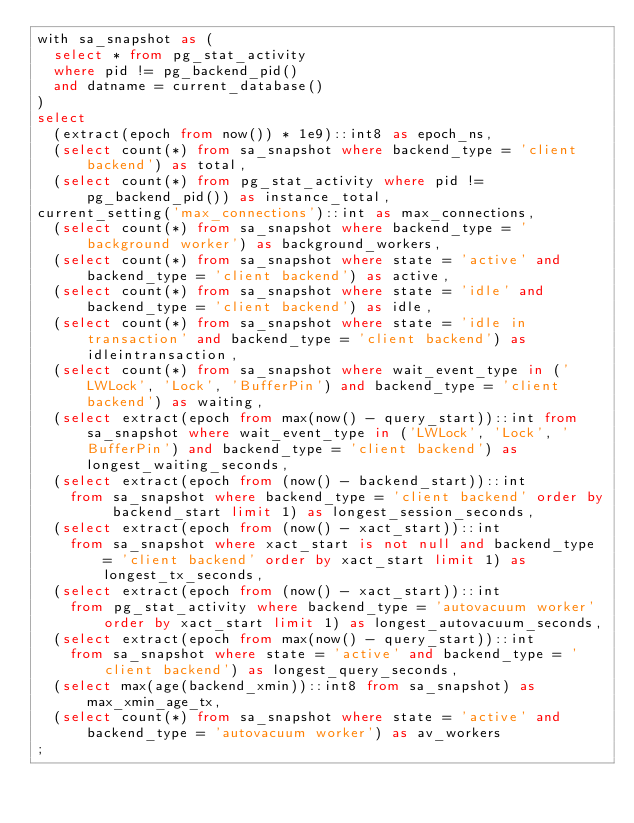<code> <loc_0><loc_0><loc_500><loc_500><_SQL_>with sa_snapshot as (
  select * from pg_stat_activity
  where pid != pg_backend_pid()
  and datname = current_database()
)
select
  (extract(epoch from now()) * 1e9)::int8 as epoch_ns,
  (select count(*) from sa_snapshot where backend_type = 'client backend') as total,
  (select count(*) from pg_stat_activity where pid != pg_backend_pid()) as instance_total,
current_setting('max_connections')::int as max_connections,
  (select count(*) from sa_snapshot where backend_type = 'background worker') as background_workers,
  (select count(*) from sa_snapshot where state = 'active' and backend_type = 'client backend') as active,
  (select count(*) from sa_snapshot where state = 'idle' and backend_type = 'client backend') as idle,
  (select count(*) from sa_snapshot where state = 'idle in transaction' and backend_type = 'client backend') as idleintransaction,
  (select count(*) from sa_snapshot where wait_event_type in ('LWLock', 'Lock', 'BufferPin') and backend_type = 'client backend') as waiting,
  (select extract(epoch from max(now() - query_start))::int from sa_snapshot where wait_event_type in ('LWLock', 'Lock', 'BufferPin') and backend_type = 'client backend') as longest_waiting_seconds,
  (select extract(epoch from (now() - backend_start))::int
    from sa_snapshot where backend_type = 'client backend' order by backend_start limit 1) as longest_session_seconds,
  (select extract(epoch from (now() - xact_start))::int
    from sa_snapshot where xact_start is not null and backend_type = 'client backend' order by xact_start limit 1) as longest_tx_seconds,
  (select extract(epoch from (now() - xact_start))::int
    from pg_stat_activity where backend_type = 'autovacuum worker' order by xact_start limit 1) as longest_autovacuum_seconds,
  (select extract(epoch from max(now() - query_start))::int
    from sa_snapshot where state = 'active' and backend_type = 'client backend') as longest_query_seconds,
  (select max(age(backend_xmin))::int8 from sa_snapshot) as max_xmin_age_tx,
  (select count(*) from sa_snapshot where state = 'active' and backend_type = 'autovacuum worker') as av_workers
;
</code> 